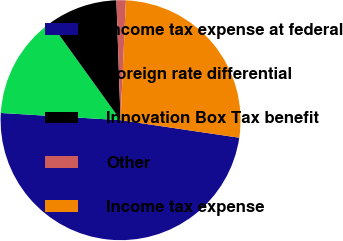Convert chart to OTSL. <chart><loc_0><loc_0><loc_500><loc_500><pie_chart><fcel>Income tax expense at federal<fcel>Foreign rate differential<fcel>Innovation Box Tax benefit<fcel>Other<fcel>Income tax expense<nl><fcel>48.62%<fcel>14.11%<fcel>9.38%<fcel>1.26%<fcel>26.63%<nl></chart> 